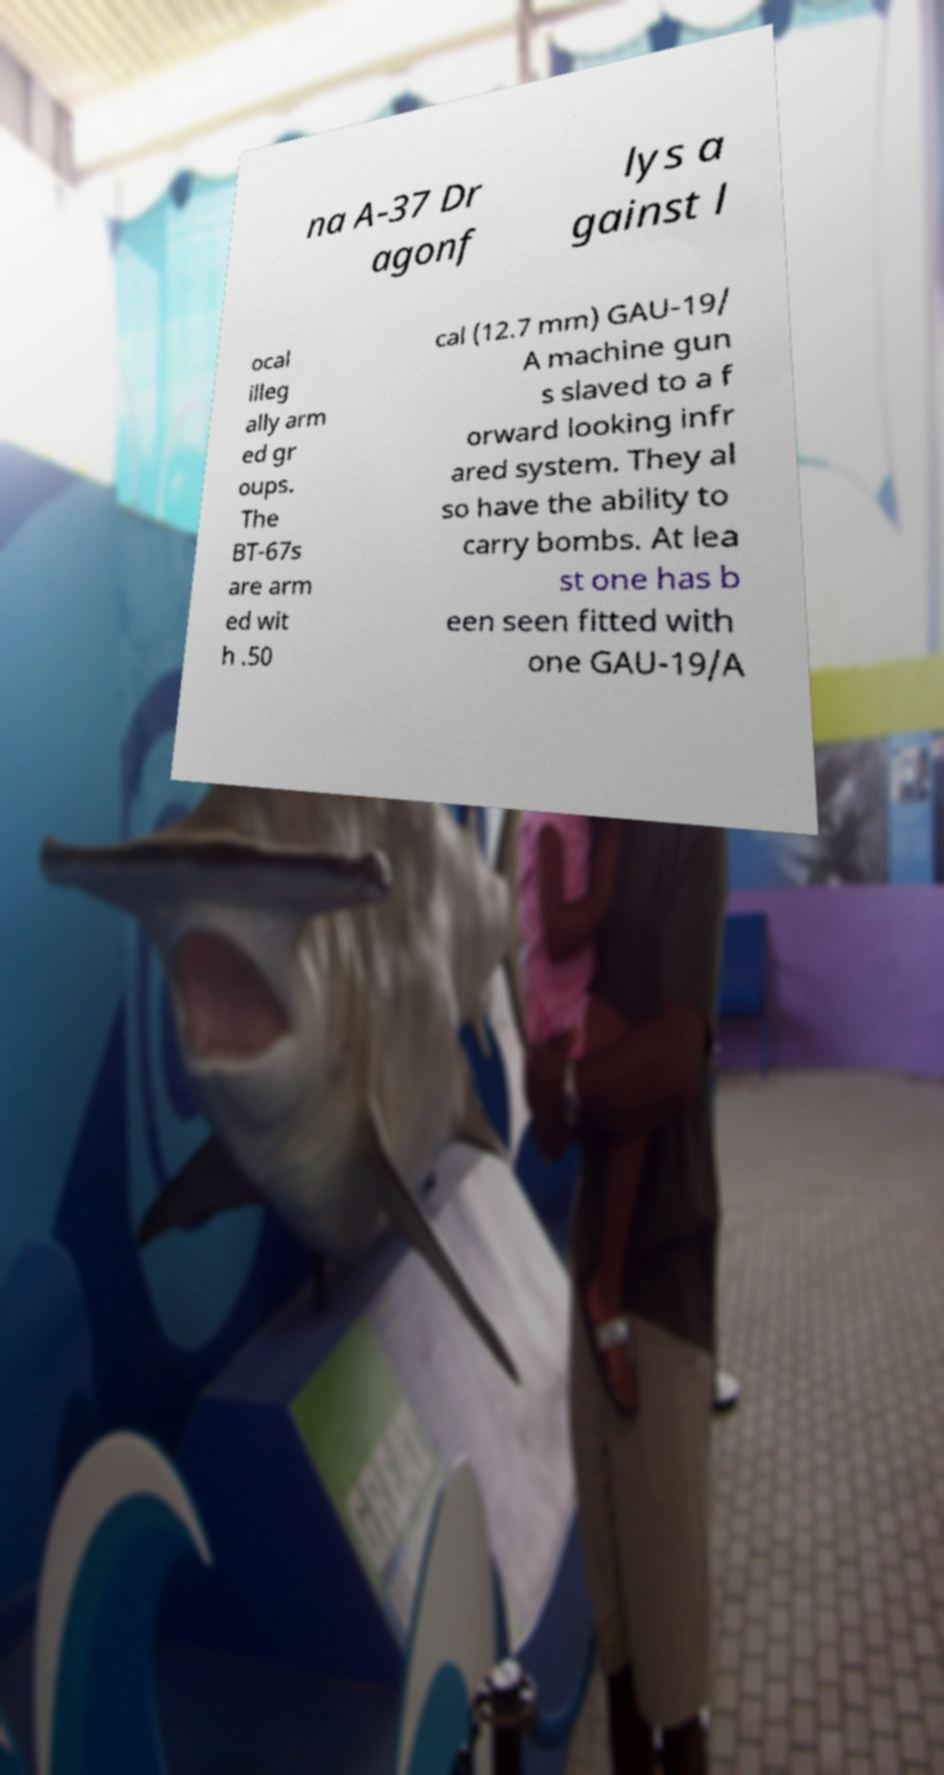Could you assist in decoding the text presented in this image and type it out clearly? na A-37 Dr agonf lys a gainst l ocal illeg ally arm ed gr oups. The BT-67s are arm ed wit h .50 cal (12.7 mm) GAU-19/ A machine gun s slaved to a f orward looking infr ared system. They al so have the ability to carry bombs. At lea st one has b een seen fitted with one GAU-19/A 